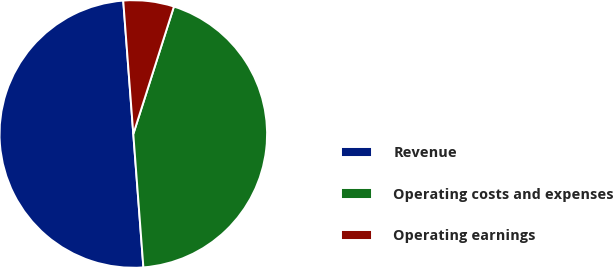Convert chart. <chart><loc_0><loc_0><loc_500><loc_500><pie_chart><fcel>Revenue<fcel>Operating costs and expenses<fcel>Operating earnings<nl><fcel>50.0%<fcel>43.89%<fcel>6.11%<nl></chart> 